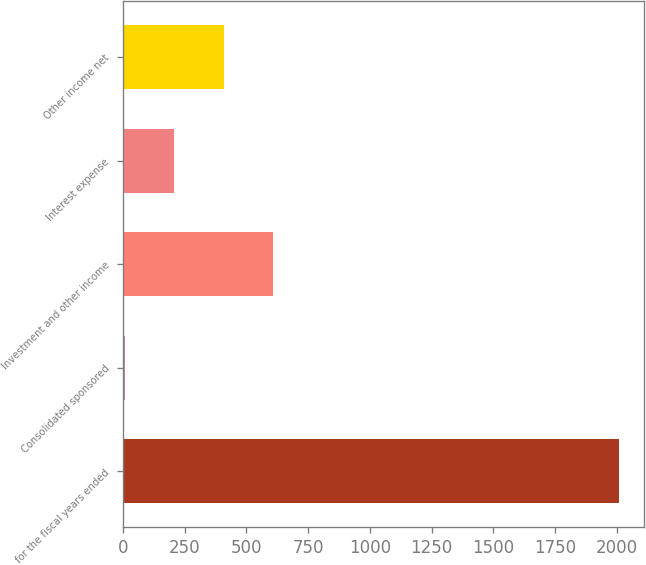Convert chart. <chart><loc_0><loc_0><loc_500><loc_500><bar_chart><fcel>for the fiscal years ended<fcel>Consolidated sponsored<fcel>Investment and other income<fcel>Interest expense<fcel>Other income net<nl><fcel>2010<fcel>8.5<fcel>608.95<fcel>208.65<fcel>408.8<nl></chart> 